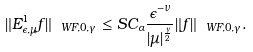<formula> <loc_0><loc_0><loc_500><loc_500>\| E ^ { 1 } _ { \epsilon , \mu } f \| _ { \ W F , 0 , \gamma } \leq S C _ { \alpha } \frac { \epsilon ^ { - \nu } } { | \mu | ^ { \frac { \gamma } { 2 } } } \| f \| _ { \ W F , 0 , \gamma } .</formula> 